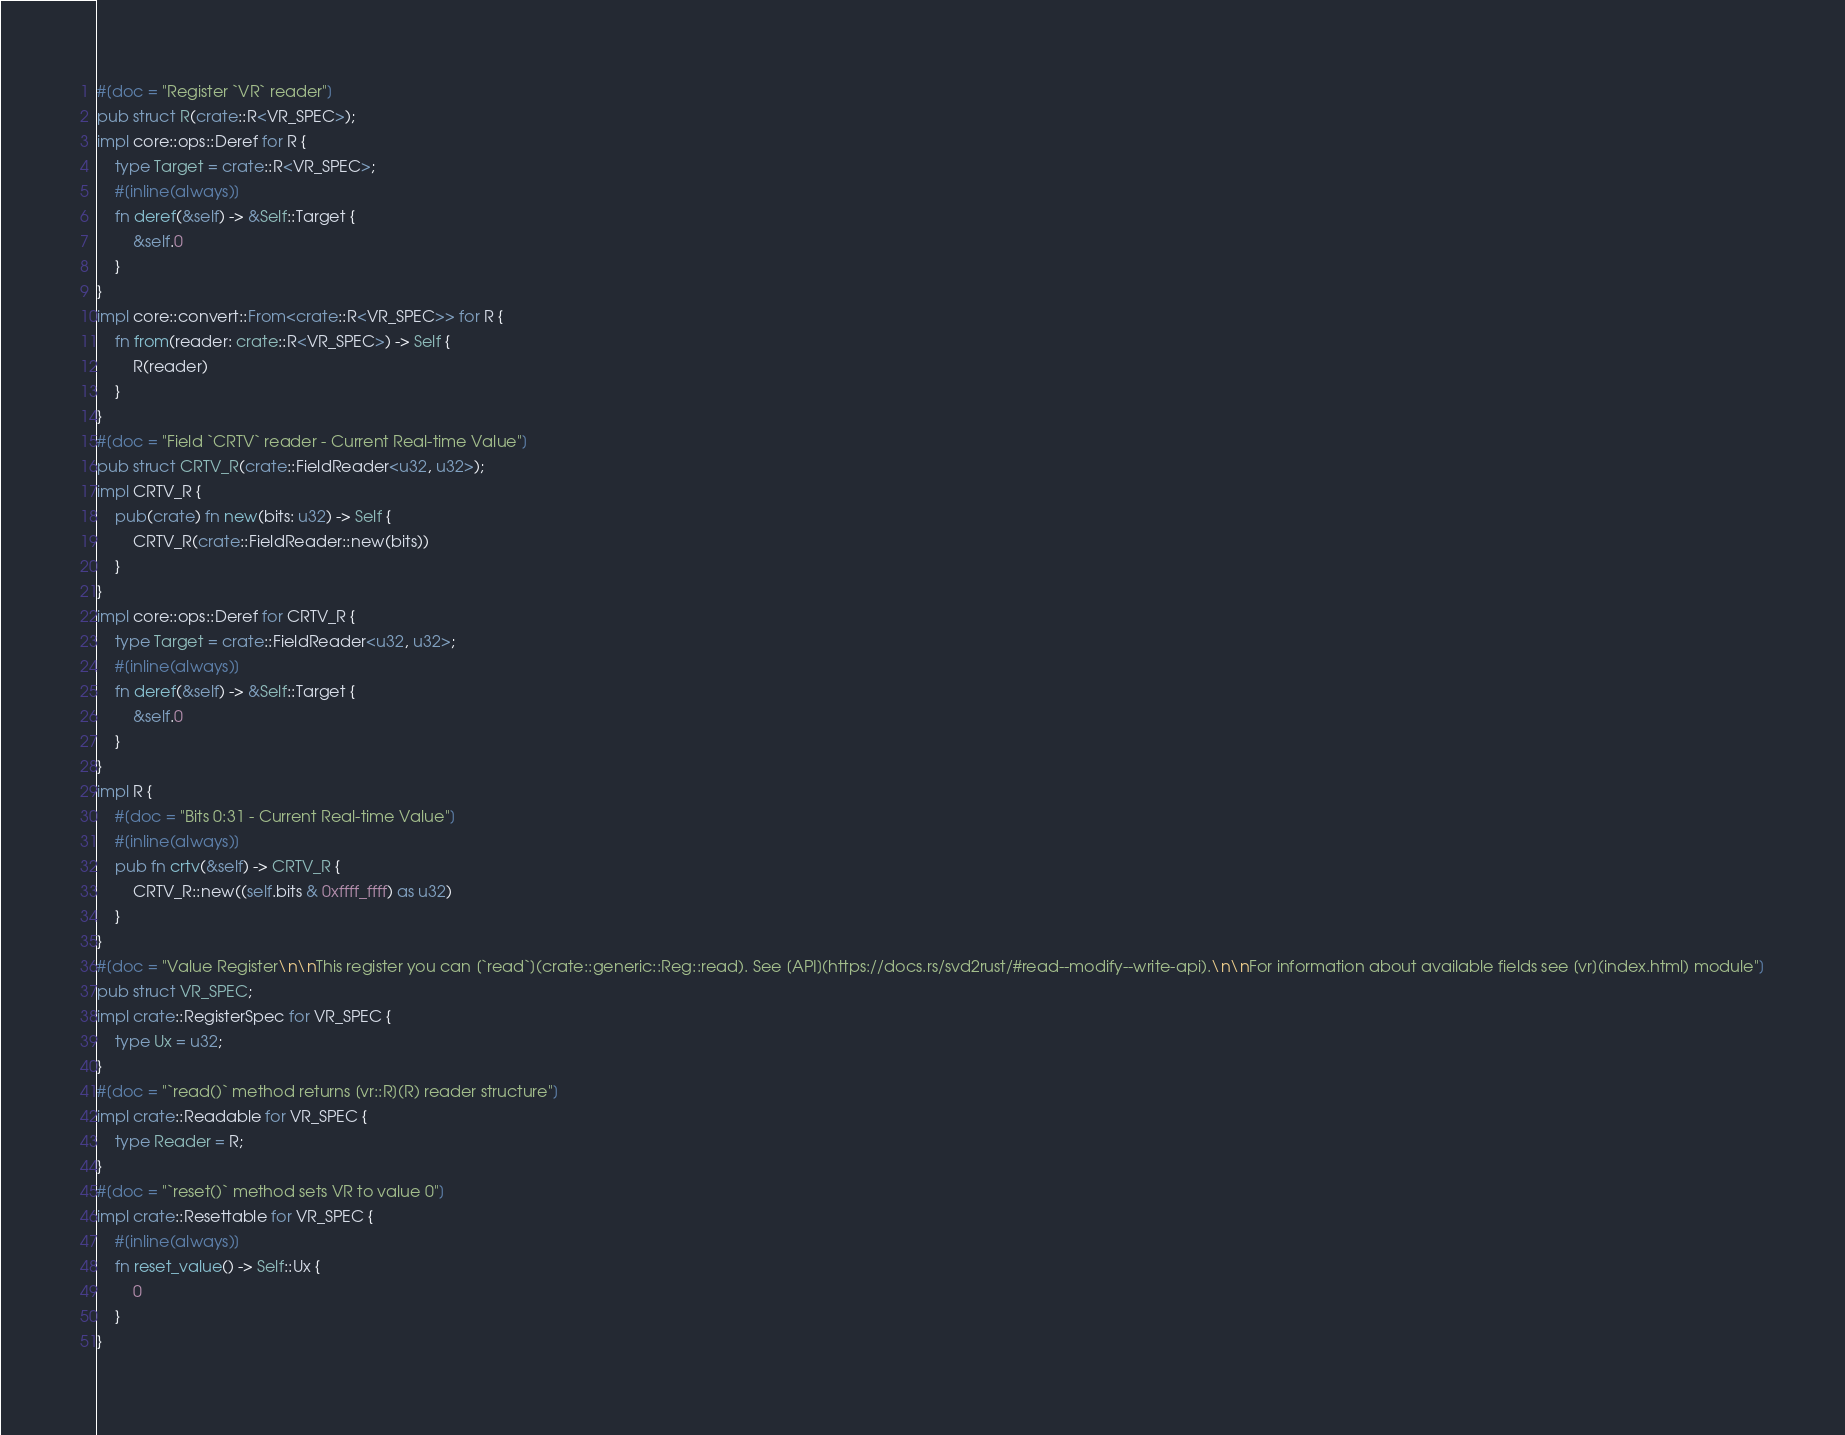Convert code to text. <code><loc_0><loc_0><loc_500><loc_500><_Rust_>#[doc = "Register `VR` reader"]
pub struct R(crate::R<VR_SPEC>);
impl core::ops::Deref for R {
    type Target = crate::R<VR_SPEC>;
    #[inline(always)]
    fn deref(&self) -> &Self::Target {
        &self.0
    }
}
impl core::convert::From<crate::R<VR_SPEC>> for R {
    fn from(reader: crate::R<VR_SPEC>) -> Self {
        R(reader)
    }
}
#[doc = "Field `CRTV` reader - Current Real-time Value"]
pub struct CRTV_R(crate::FieldReader<u32, u32>);
impl CRTV_R {
    pub(crate) fn new(bits: u32) -> Self {
        CRTV_R(crate::FieldReader::new(bits))
    }
}
impl core::ops::Deref for CRTV_R {
    type Target = crate::FieldReader<u32, u32>;
    #[inline(always)]
    fn deref(&self) -> &Self::Target {
        &self.0
    }
}
impl R {
    #[doc = "Bits 0:31 - Current Real-time Value"]
    #[inline(always)]
    pub fn crtv(&self) -> CRTV_R {
        CRTV_R::new((self.bits & 0xffff_ffff) as u32)
    }
}
#[doc = "Value Register\n\nThis register you can [`read`](crate::generic::Reg::read). See [API](https://docs.rs/svd2rust/#read--modify--write-api).\n\nFor information about available fields see [vr](index.html) module"]
pub struct VR_SPEC;
impl crate::RegisterSpec for VR_SPEC {
    type Ux = u32;
}
#[doc = "`read()` method returns [vr::R](R) reader structure"]
impl crate::Readable for VR_SPEC {
    type Reader = R;
}
#[doc = "`reset()` method sets VR to value 0"]
impl crate::Resettable for VR_SPEC {
    #[inline(always)]
    fn reset_value() -> Self::Ux {
        0
    }
}
</code> 